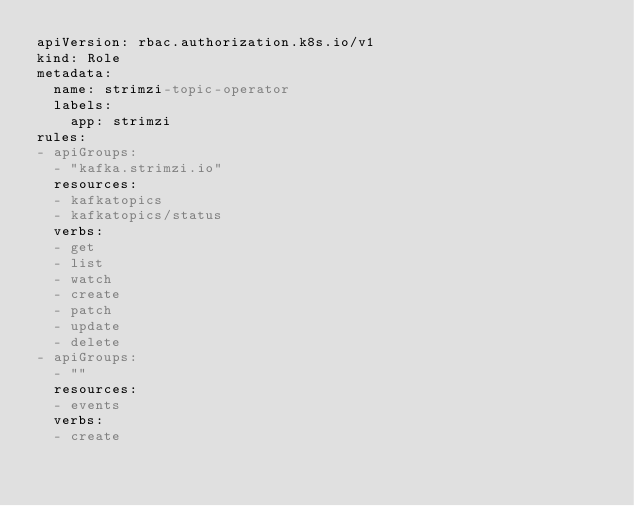<code> <loc_0><loc_0><loc_500><loc_500><_YAML_>apiVersion: rbac.authorization.k8s.io/v1
kind: Role
metadata:
  name: strimzi-topic-operator
  labels:
    app: strimzi
rules:
- apiGroups:
  - "kafka.strimzi.io"
  resources:
  - kafkatopics
  - kafkatopics/status
  verbs:
  - get
  - list
  - watch
  - create
  - patch
  - update
  - delete
- apiGroups:
  - ""
  resources:
  - events
  verbs:
  - create</code> 